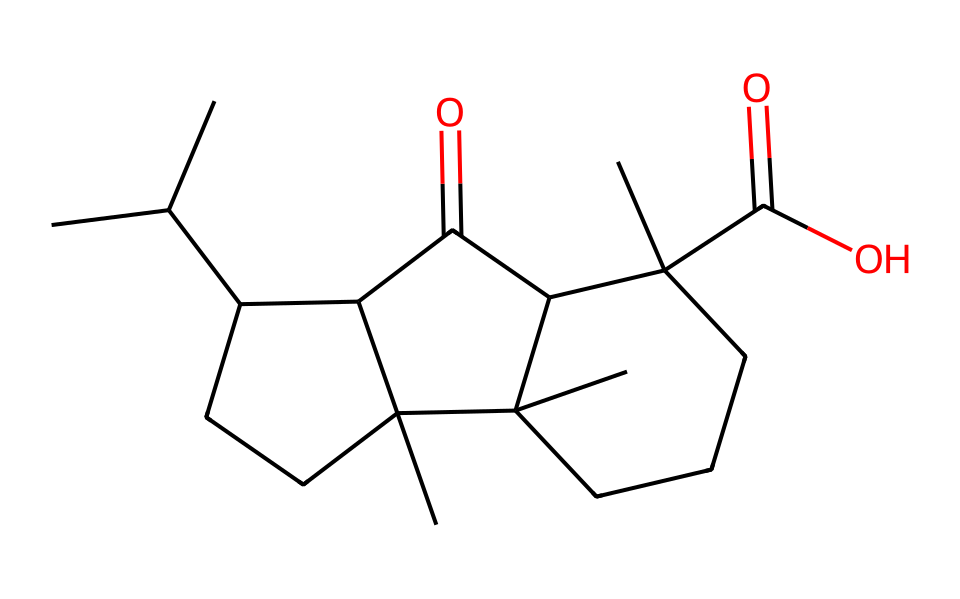What is the molecular formula of this compound? By analyzing the SMILES representation, we can count the number of carbon (C), hydrogen (H), and oxygen (O) atoms present. There are 27 carbon atoms, 42 hydrogen atoms, and 2 oxygen atoms in total. Thus, the molecular formula is C27H42O2.
Answer: C27H42O2 How many rings are present in the structure? Reviewing the SMILES structure, we identify that it contains several 'C' connected in a way that forms closed loops, indicating there are 2 distinct rings present.
Answer: 2 What functional groups are present in this compound? Looking at the structure, the presence of carbonyl groups (C=O) is indicated by 'C(=O)', which corresponds to ketones. Additionally, a carboxylic acid group is observed through 'C(=O)O'. Therefore, ketone and carboxylic acid are the functional groups.
Answer: ketone and carboxylic acid Is this compound a polar or non-polar substance? Assessing the structure reveals that the majority of the compound consists of long hydrocarbon chains devoid of polar functional groups, which indicates that it is predominantly non-polar. Specifically, the presence of only two polar functional groups (ketone and carboxylic acid) does not significantly affect the overall non-polar nature, leading to the conclusion that it is a non-electrolyte.
Answer: non-polar How many chiral centers are present in the compound? In the SMILES representation, chiral centers are identified by carbon atoms attached to four different substituents. Running through the structure, only one carbon atom appears to fit this description, indicating there is one chiral center in the compound.
Answer: 1 